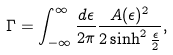<formula> <loc_0><loc_0><loc_500><loc_500>\Gamma = \int _ { - \infty } ^ { \infty } \frac { d \epsilon } { 2 \pi } \frac { A ( \epsilon ) ^ { 2 } } { 2 \sinh ^ { 2 } \frac { \epsilon } { 2 } } ,</formula> 